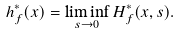Convert formula to latex. <formula><loc_0><loc_0><loc_500><loc_500>h _ { f } ^ { * } ( x ) = \liminf _ { s \to 0 } H _ { f } ^ { * } ( x , s ) .</formula> 